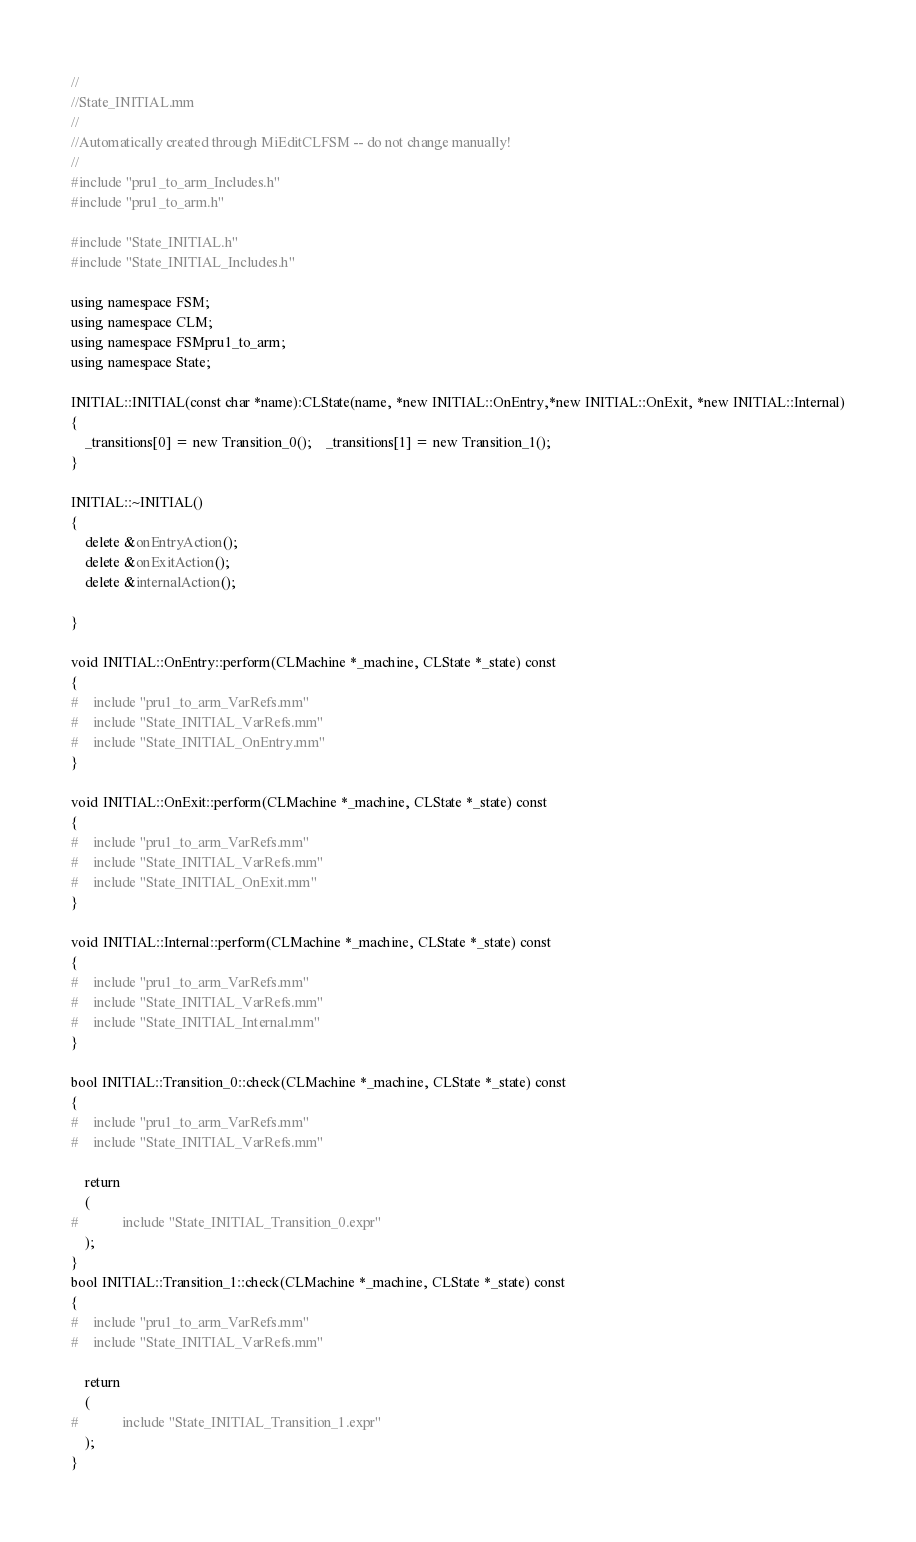Convert code to text. <code><loc_0><loc_0><loc_500><loc_500><_ObjectiveC_>//
//State_INITIAL.mm
//
//Automatically created through MiEditCLFSM -- do not change manually!
//
#include "pru1_to_arm_Includes.h"
#include "pru1_to_arm.h"

#include "State_INITIAL.h"
#include "State_INITIAL_Includes.h"

using namespace FSM;
using namespace CLM;
using namespace FSMpru1_to_arm;
using namespace State;

INITIAL::INITIAL(const char *name):CLState(name, *new INITIAL::OnEntry,*new INITIAL::OnExit, *new INITIAL::Internal)
{
	_transitions[0] = new Transition_0();	_transitions[1] = new Transition_1();
}

INITIAL::~INITIAL()
{
	delete &onEntryAction();
	delete &onExitAction();
	delete &internalAction();

}

void INITIAL::OnEntry::perform(CLMachine *_machine, CLState *_state) const
{
#	include "pru1_to_arm_VarRefs.mm"
#	include "State_INITIAL_VarRefs.mm"
#	include "State_INITIAL_OnEntry.mm"
}

void INITIAL::OnExit::perform(CLMachine *_machine, CLState *_state) const
{
#	include "pru1_to_arm_VarRefs.mm"
#	include "State_INITIAL_VarRefs.mm"
#	include "State_INITIAL_OnExit.mm"
}

void INITIAL::Internal::perform(CLMachine *_machine, CLState *_state) const
{
#	include "pru1_to_arm_VarRefs.mm"
#	include "State_INITIAL_VarRefs.mm"
#	include "State_INITIAL_Internal.mm"
}

bool INITIAL::Transition_0::check(CLMachine *_machine, CLState *_state) const
{
#	include "pru1_to_arm_VarRefs.mm"
#	include "State_INITIAL_VarRefs.mm"

	return
	(
#			include "State_INITIAL_Transition_0.expr"
	);
}
bool INITIAL::Transition_1::check(CLMachine *_machine, CLState *_state) const
{
#	include "pru1_to_arm_VarRefs.mm"
#	include "State_INITIAL_VarRefs.mm"

	return
	(
#			include "State_INITIAL_Transition_1.expr"
	);
}


</code> 